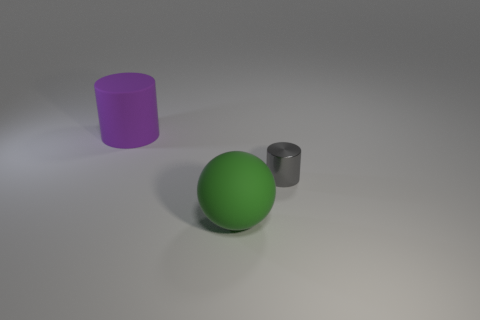How many objects are either cylinders in front of the large rubber cylinder or objects that are to the left of the small thing?
Offer a terse response. 3. Are there fewer gray things that are left of the green matte object than small green things?
Make the answer very short. No. Are there any purple cylinders that have the same size as the matte sphere?
Provide a short and direct response. Yes. The tiny shiny cylinder is what color?
Offer a terse response. Gray. Do the green ball and the purple rubber cylinder have the same size?
Make the answer very short. Yes. What number of objects are big purple cylinders or small metallic things?
Your answer should be compact. 2. Is the number of tiny gray metallic cylinders that are left of the big sphere the same as the number of tiny gray shiny blocks?
Make the answer very short. Yes. Are there any metallic objects to the right of the big rubber thing in front of the cylinder behind the metallic thing?
Your answer should be compact. Yes. What color is the other thing that is made of the same material as the purple thing?
Provide a short and direct response. Green. There is a large thing that is behind the small metal cylinder; does it have the same color as the shiny object?
Make the answer very short. No. 